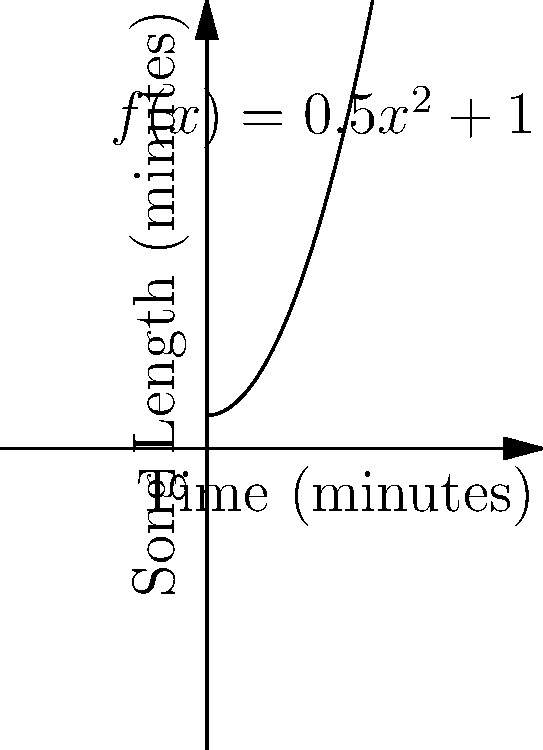As a radio station director, you're creating a special playlist where song lengths follow the function $f(x) = 0.5x^2 + 1$, where $x$ is the time in minutes since the playlist started and $f(x)$ is the length of the song in minutes. If you want the total playlist duration to be exactly 15 minutes, how many songs should be included? Use integral calculus to solve this problem. To solve this problem, we need to follow these steps:

1) The total duration of the playlist is the integral of the song length function from 0 to the end time $t$:

   $$\int_0^t (0.5x^2 + 1) dx = 15$$

2) Evaluate the integral:

   $$[\frac{1}{6}x^3 + x]_0^t = 15$$

3) Simplify:

   $$\frac{1}{6}t^3 + t = 15$$

4) Rearrange the equation:

   $$\frac{1}{6}t^3 + t - 15 = 0$$

5) This is a cubic equation. It can be solved numerically or by graphing. The solution is approximately $t = 3.915$ minutes.

6) To find the number of songs, we need to count how many complete songs fit within this time. We can do this by integrating $\frac{1}{f(x)}$ from 0 to 3.915:

   $$\int_0^{3.915} \frac{1}{0.5x^2 + 1} dx$$

7) This integral doesn't have a simple closed form, but we can evaluate it numerically to get approximately 3.

Therefore, the playlist should include 3 songs to get as close as possible to the 15-minute duration.
Answer: 3 songs 